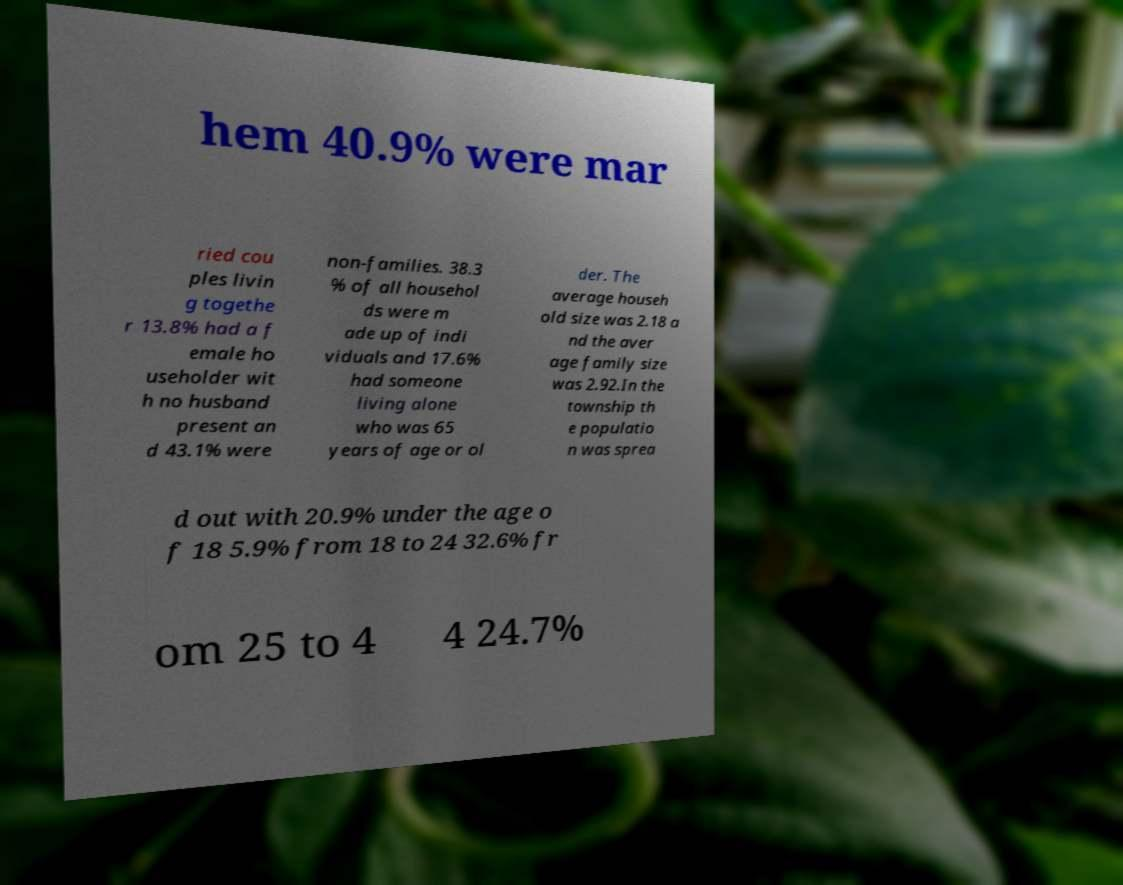Could you extract and type out the text from this image? hem 40.9% were mar ried cou ples livin g togethe r 13.8% had a f emale ho useholder wit h no husband present an d 43.1% were non-families. 38.3 % of all househol ds were m ade up of indi viduals and 17.6% had someone living alone who was 65 years of age or ol der. The average househ old size was 2.18 a nd the aver age family size was 2.92.In the township th e populatio n was sprea d out with 20.9% under the age o f 18 5.9% from 18 to 24 32.6% fr om 25 to 4 4 24.7% 